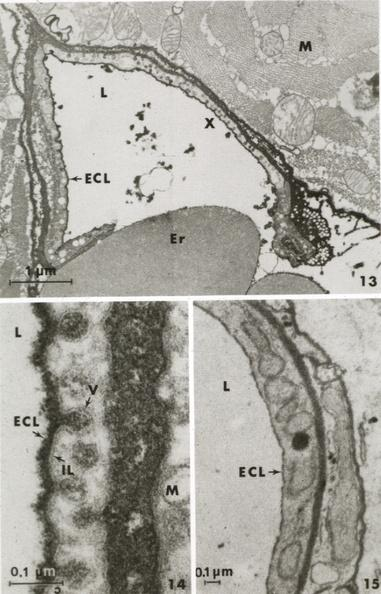what does this image show?
Answer the question using a single word or phrase. Muscle ruthenium red to illustrate glycocalyx 